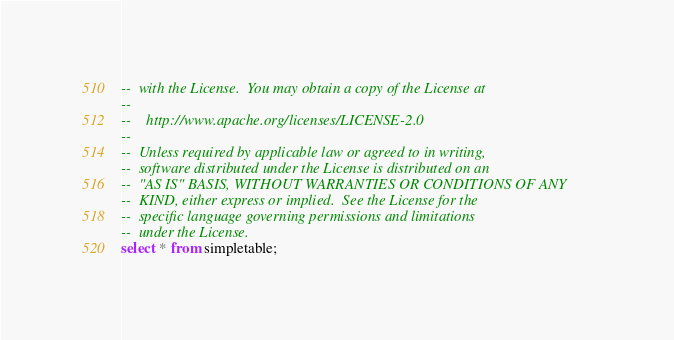Convert code to text. <code><loc_0><loc_0><loc_500><loc_500><_SQL_>--  with the License.  You may obtain a copy of the License at
--
--    http://www.apache.org/licenses/LICENSE-2.0
--
--  Unless required by applicable law or agreed to in writing,
--  software distributed under the License is distributed on an
--  "AS IS" BASIS, WITHOUT WARRANTIES OR CONDITIONS OF ANY
--  KIND, either express or implied.  See the License for the
--  specific language governing permissions and limitations
--  under the License.
select * from simpletable;</code> 